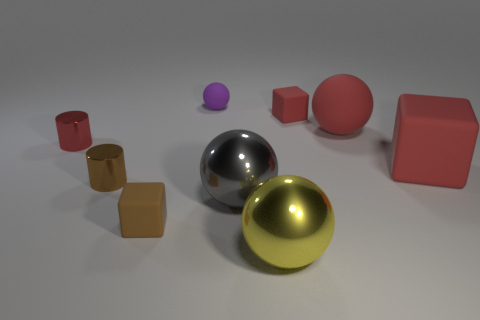Subtract all red matte cubes. How many cubes are left? 1 Subtract all gray balls. How many balls are left? 3 Add 1 large gray metallic objects. How many objects exist? 10 Subtract 1 balls. How many balls are left? 3 Subtract all cylinders. How many objects are left? 7 Subtract all purple cylinders. How many red balls are left? 1 Subtract all big blue rubber objects. Subtract all brown blocks. How many objects are left? 8 Add 8 metallic cylinders. How many metallic cylinders are left? 10 Add 9 large brown shiny objects. How many large brown shiny objects exist? 9 Subtract 0 cyan blocks. How many objects are left? 9 